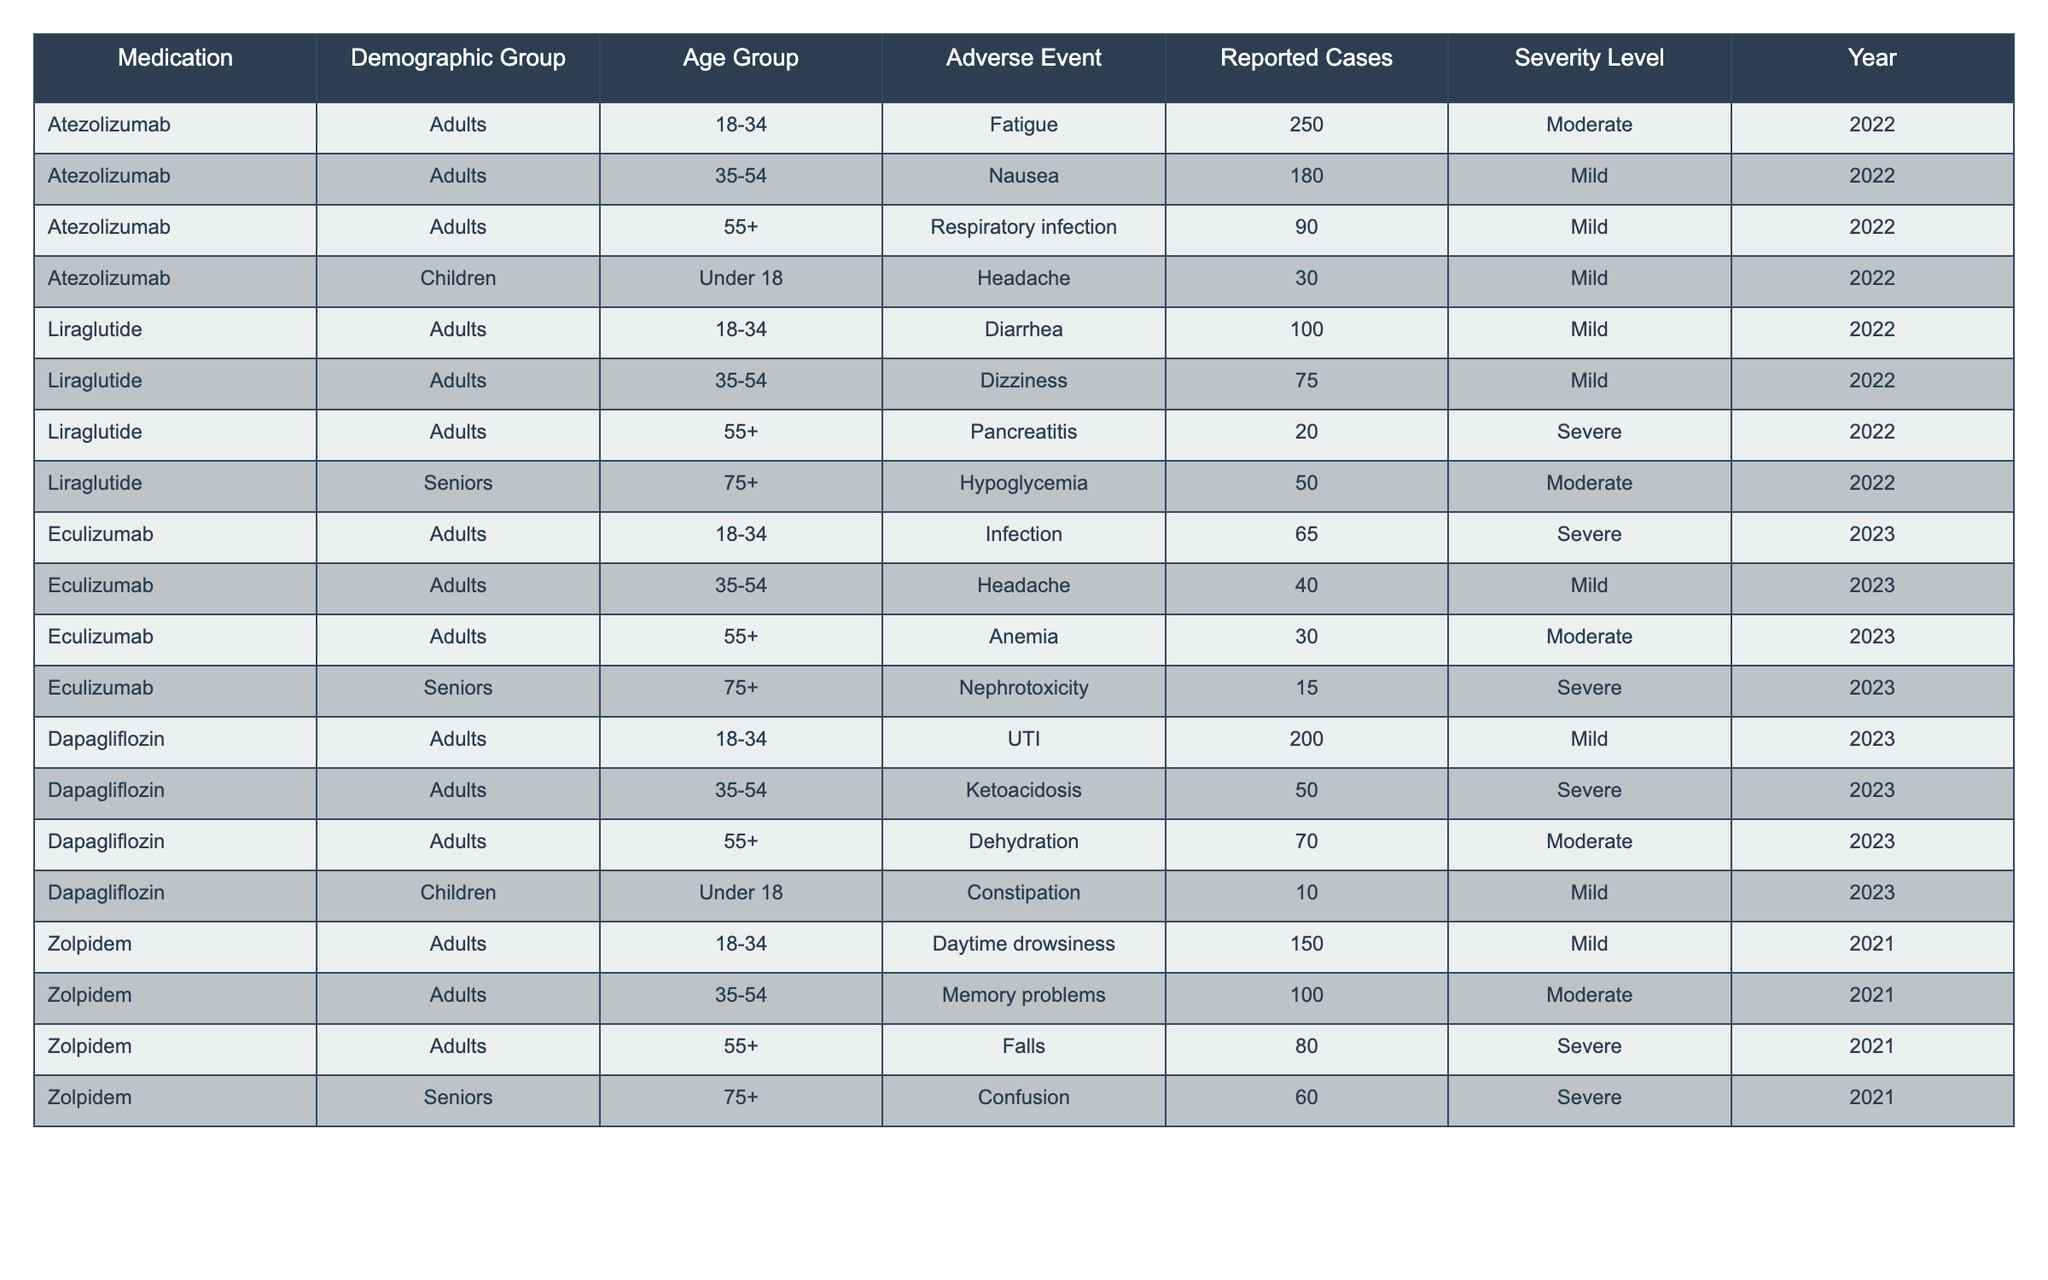What is the most reported adverse event for Atezolizumab in the 18-34 age group? According to the table, the most reported adverse event for Atezolizumab in the 18-34 age group is Fatigue, with 250 reported cases in 2022.
Answer: Fatigue Which demographic group reported the highest number of adverse events for Liraglutide? The table indicates that adults in the 18-34 age group reported the highest number of adverse events for Liraglutide, with a total of 100 cases of Diarrhea in 2022.
Answer: Adults 18-34 What is the total number of reported cases for Eculizumab across all age groups and severity levels in 2023? The reported cases for Eculizumab in 2023 are 65 (Infection) + 40 (Headache) + 30 (Anemia) + 15 (Nephrotoxicity) = 150 total reported cases.
Answer: 150 For which adverse event was the severity level categorized as Severe in Seniors aged 75+? The table shows that the only adverse event classified as Severe for Seniors aged 75+ was Confusion for Zolpidem in 2021, with 60 reported cases.
Answer: Confusion What demographics reported fatigue or drowsiness as an adverse event and what were their reported cases? Fatigue was reported by the Atezolizumab group (Adults, 18-34, 250 cases) and daytime drowsiness was reported by Zolpidem (Adults, 18-34, 150 cases). The total reported cases for both events is 400.
Answer: 400 Is it true that all adverse events reported for Dapagliflozin were mild? No, it is not true. The table shows that Ketoacidosis was reported as a Severe adverse event in the 35-54 age group, contradicting the claim that all were mild.
Answer: False What percentage of adverse events in the 55+ demographic group for Liraglutide were classified as Severe? For Liraglutide, there were a total of 20 cases of pancreatitis (Severe) among 95 total cases (20 + 75). Thus, 20/95 * 100 = 21.1% were classified as Severe.
Answer: 21.1% Which age group showed the least number of reported cases for any adverse event in 2022? The Children under 18 demographic reported the least number of adverse events in 2022, with only 30 cases of Headache associated with Atezolizumab.
Answer: 30 